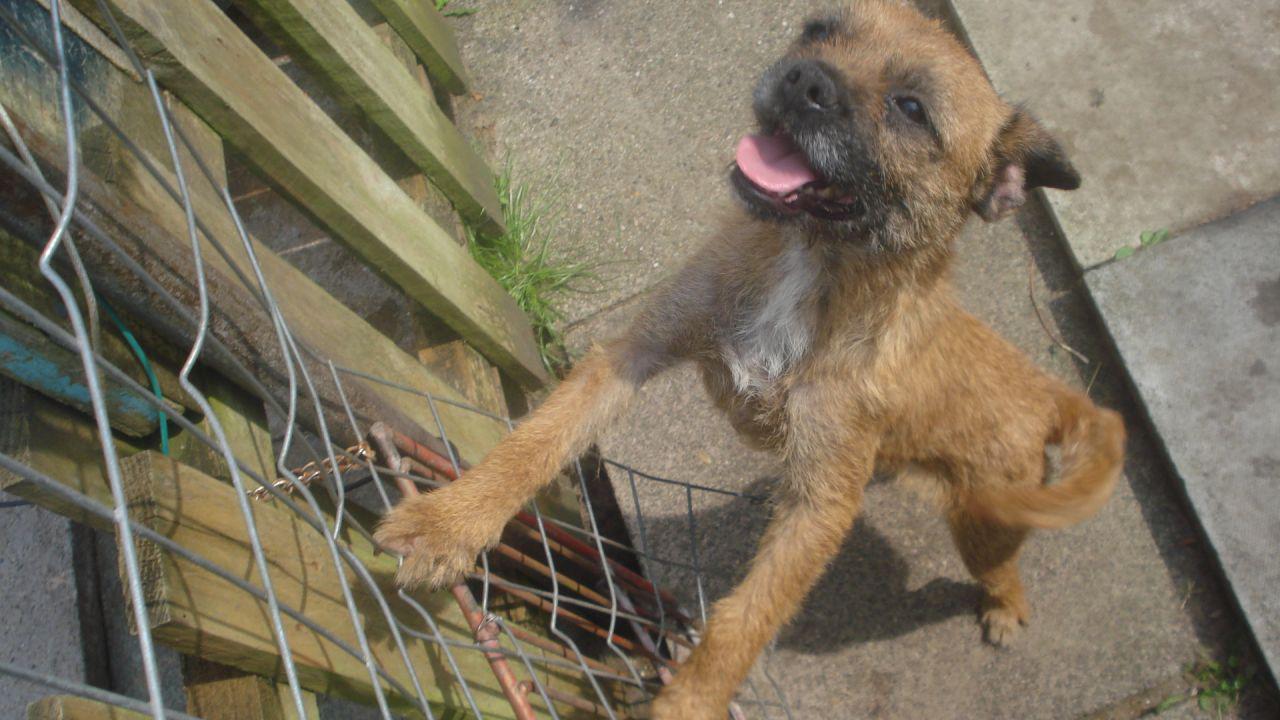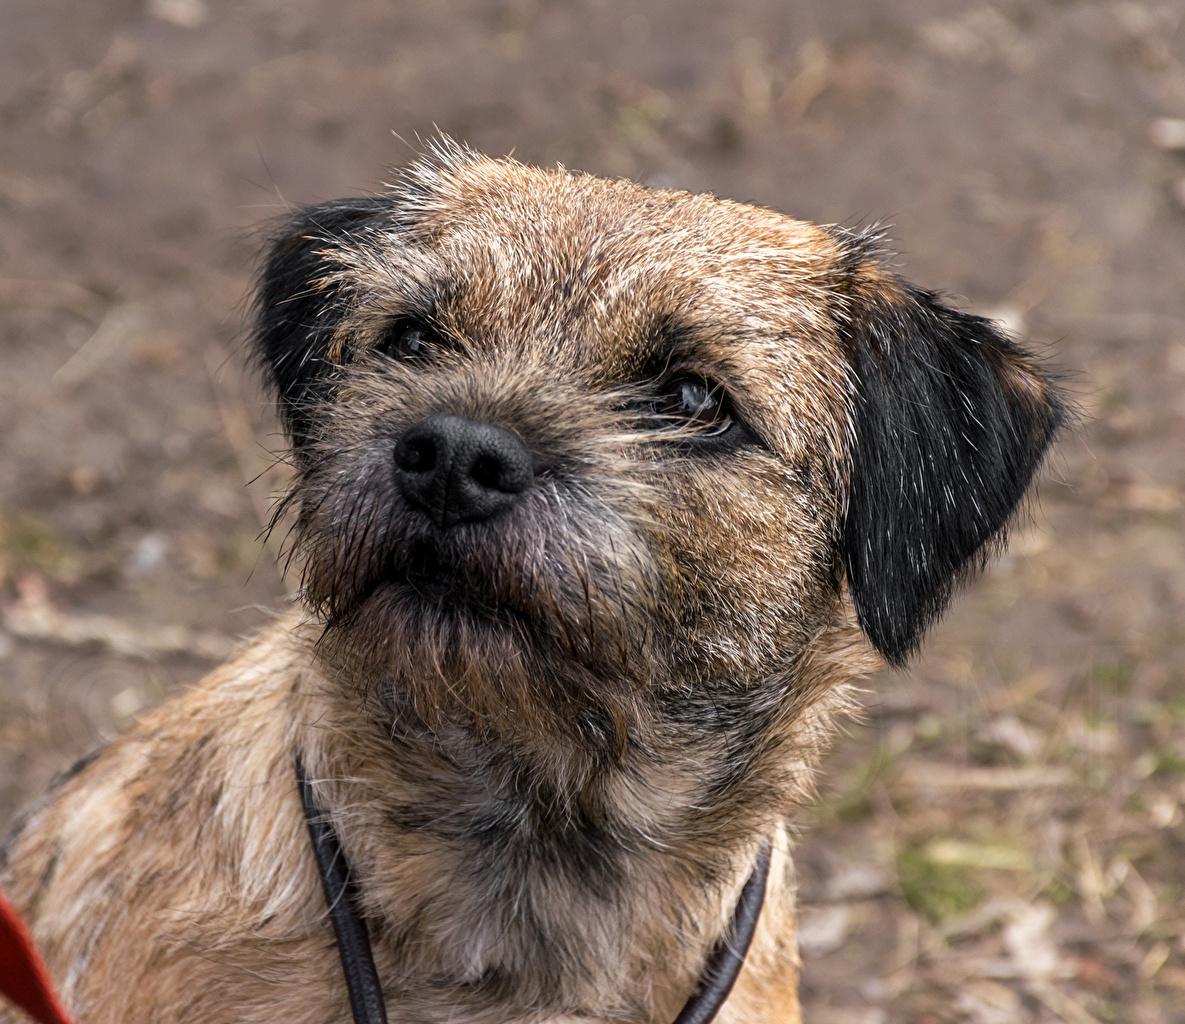The first image is the image on the left, the second image is the image on the right. Assess this claim about the two images: "In one of the two images, the dog is displaying his tongue.". Correct or not? Answer yes or no. Yes. 